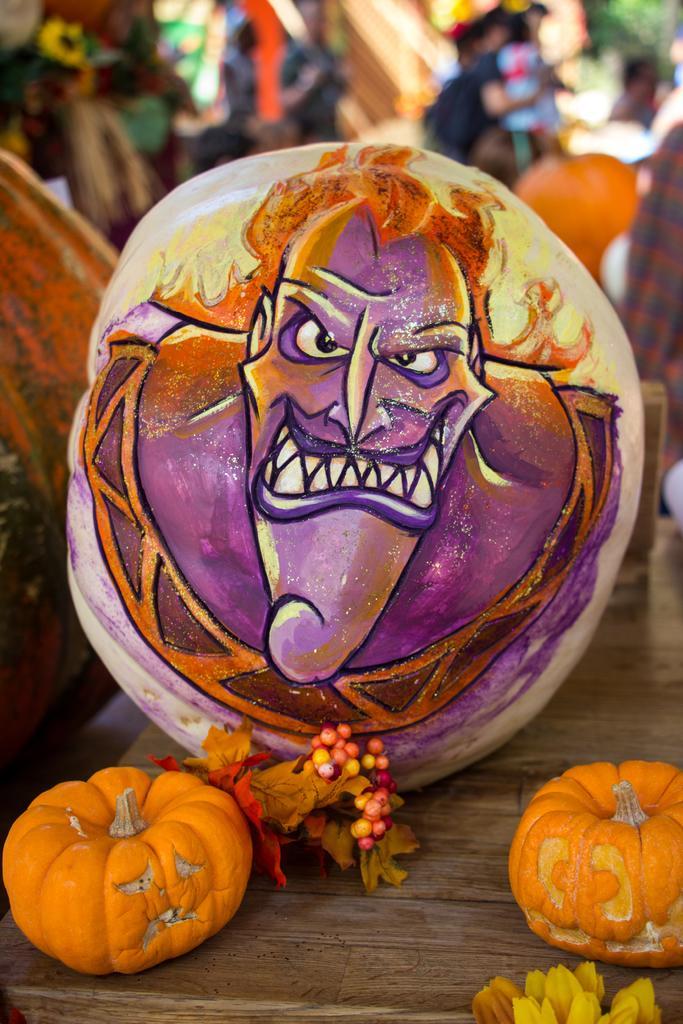Describe this image in one or two sentences. In the foreground of the picture there are pumpkin, flowers and leaves on a wooden table. In the center of the picture there is a painting, on the pumpkin. The background is blurred. 